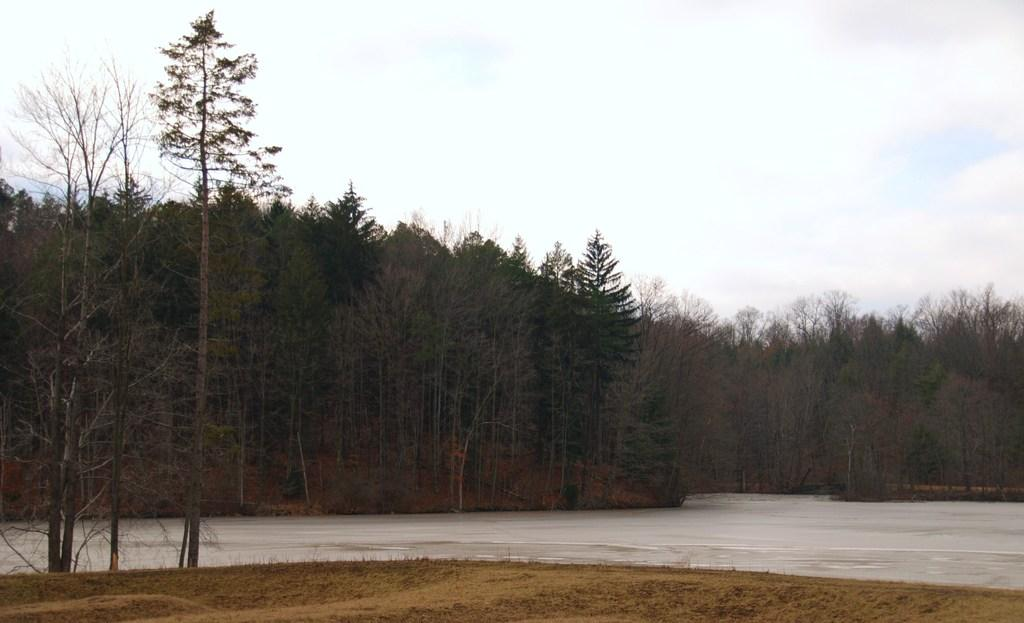What is the primary feature of the image? The primary feature of the image is a water surface. What can be seen around the water surface? There are many trees surrounding the water surface in the image. Where is the scarecrow located in the image? There is no scarecrow present in the image. How many mice can be seen running on the trail in the image? There is no trail or mice present in the image. 